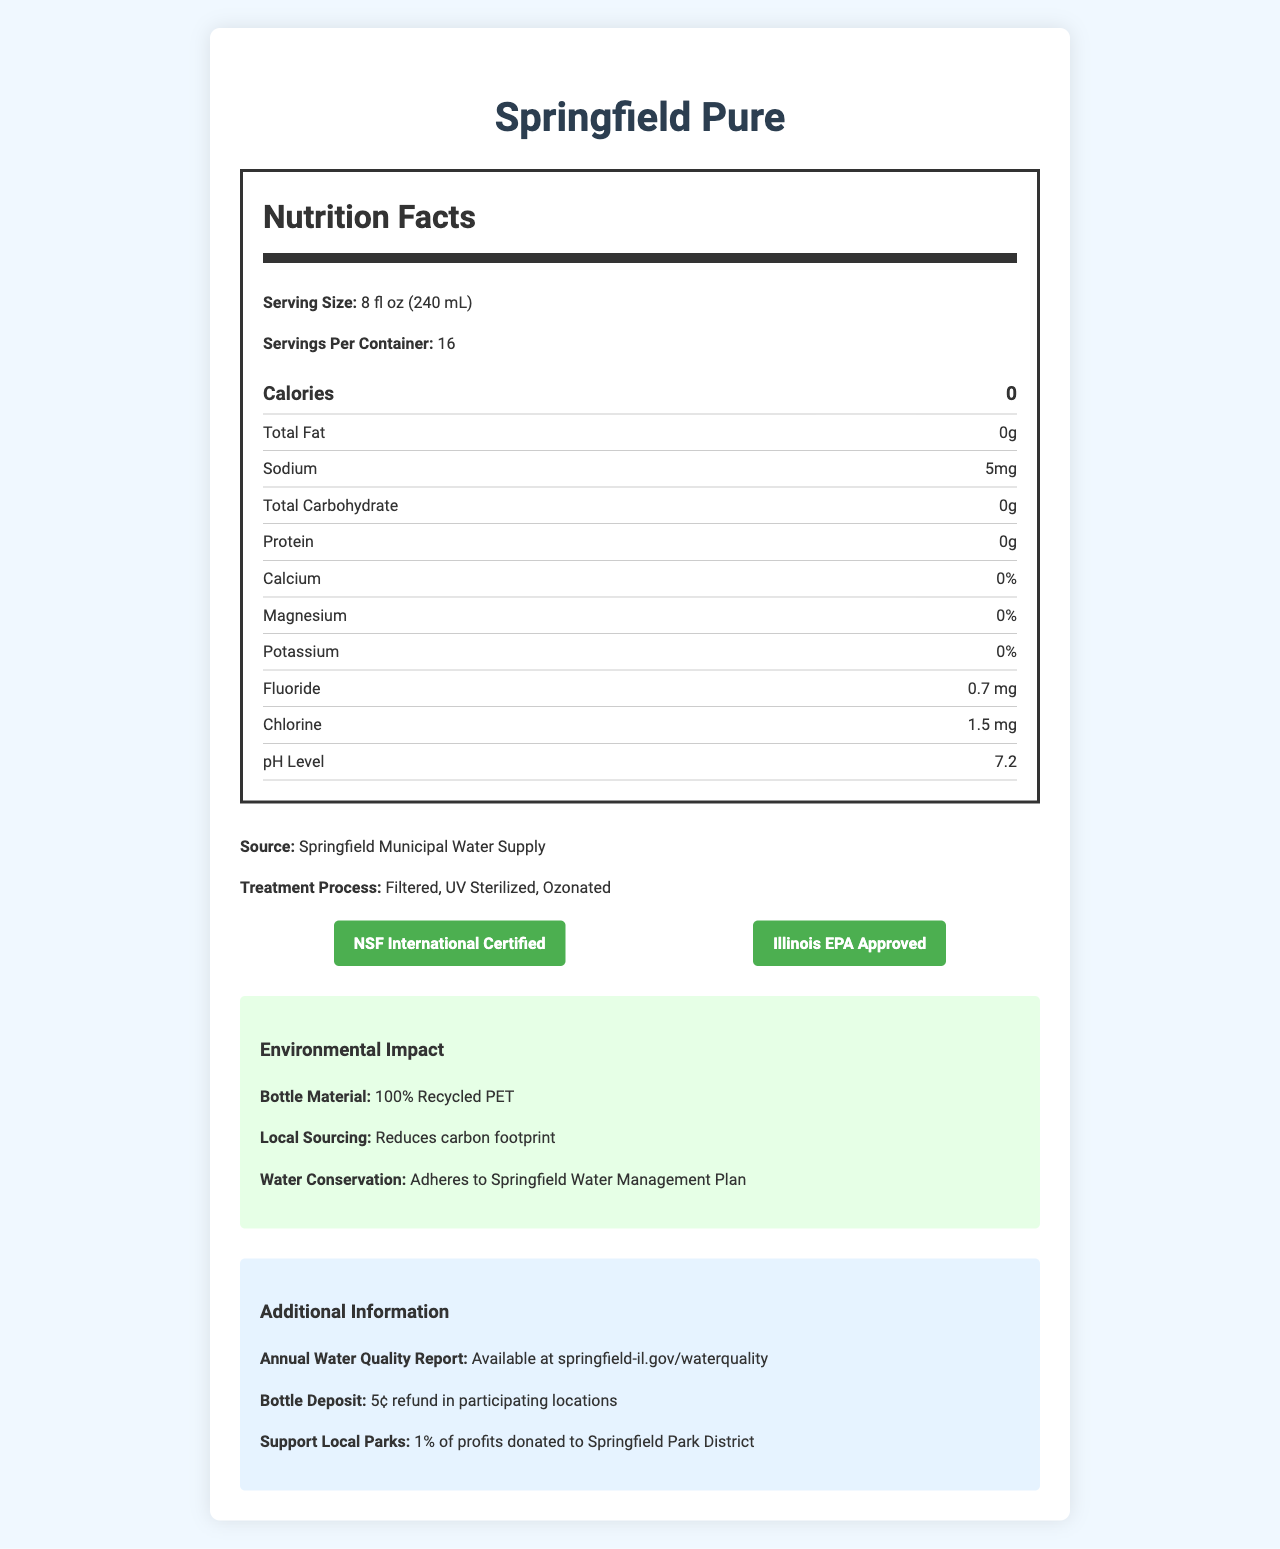what is the serving size of Springfield Pure bottled water? The serving size is stated as "8 fl oz (240 mL)" in the Nutrition Facts section of the document.
Answer: 8 fl oz (240 mL) how many servings are in one container of Springfield Pure bottled water? The document mentions "Servings Per Container: 16."
Answer: 16 what is the sodium content per serving in Springfield Pure bottled water? The sodium content is listed as "5mg" in the Nutrition Facts table.
Answer: 5 mg how much fluoride is in Springfield Pure bottled water? The document lists the fluoride content as "0.7 mg" in the Nutrition Facts table.
Answer: 0.7 mg how much of Springfield Pure’s profits are donated to the Springfield Park District? The Additional Information section states "1% of profits donated to Springfield Park District."
Answer: 1% which of the following certifications does Springfield Pure have? A. USDA Organic B. NSF International Certified C. Non-GMO Project Verified The document includes a certification badge for NSF International Certified.
Answer: B what are the three main steps in the treatment process for Springfield Pure bottled water? A. Filtration, UV Sterilization, Distillation B. Filtration, UV Sterilization, Ozonation C. Filtration, UV Sterilization, Chlorination D. Filtration, Reverse Osmosis, Ozonation The treatment process is listed as "Filtered, UV Sterilized, Ozonated."
Answer: B is the bottle material of Springfield Pure environmentally friendly? The Environmental Impact section states the bottle is made from "100% Recycled PET," indicating an environmentally friendly material.
Answer: Yes describe the main purpose of this document. The document highlights nutritional content, environmental efforts, water sourcing, treatment, and certifications, catering especially to consumers interested in the quality of Springfield's environment.
Answer: The main purpose of this document is to provide detailed nutritional and environmental information about Springfield Pure bottled water, including its source, treatment process, certifications, and additional benefits. are there any calories in Springfield Pure bottled water? The Nutrition Facts table lists "Calories: 0."
Answer: No what are the pH level and chlorine content of Springfield Pure bottled water? The Nutrition Facts table lists the pH level as "7.2" and chlorine content as "1.5 mg."
Answer: pH level: 7.2, Chlorine: 1.5 mg what is the total carbohydrate content per serving? The total carbohydrate content is listed as "0g" in the Nutrition Facts table.
Answer: 0g does Springfield Pure bottled water provide any significant amounts of calcium, magnesium, or potassium? The Nutrition Facts section indicates "0%" for calcium, magnesium, and potassium.
Answer: No where can I find the annual water quality report for Springfield Pure bottled water? The Additional Information section mentions that the annual water quality report is available at "springfield-il.gov/waterquality."
Answer: springfield-il.gov/waterquality what are the environmental benefits of local sourcing for Springfield Pure bottled water? The Environmental Impact section states that local sourcing "Reduces carbon footprint."
Answer: Reduces carbon footprint how much refund can you get for returning a bottle of Springfield Pure at participating locations? The Additional Information section mentions a "5¢ refund in participating locations."
Answer: 5¢ where is Springfield Pure bottled water sourced from? The document lists "Source: Springfield Municipal Water Supply."
Answer: Springfield Municipal Water Supply is any information about the water quality available publicly? The Additional Information section provides a link to the annual water quality report at "springfield-il.gov/waterquality."
Answer: Yes does Springfield Pure bottled water adhere to any specific water management plan? The Environmental Impact section states that the bottled water "Adheres to Springfield Water Management Plan."
Answer: Yes what are the main environmental and quality certifications for Springfield Pure? These certifications are highlighted in the certifications section with corresponding badges.
Answer: NSF International Certified, Illinois EPA Approved is Springfield Pure rich in protein content? The Nutrition Facts table lists "Protein: 0g."
Answer: No what is the magnesium content in Springfield Pure bottled water? The Nutrition Facts table lists magnesium content as "0%."
Answer: 0% is it possible to determine the exact location of treatment facilities from this document? The document does not provide specific information regarding the location of treatment facilities.
Answer: No 